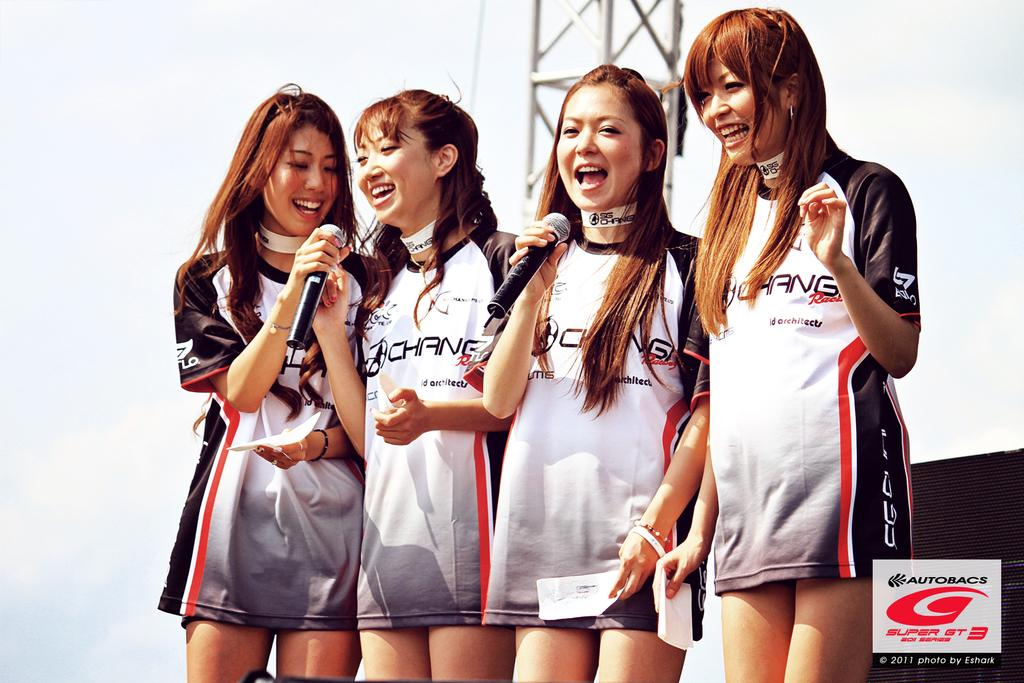<image>
Relay a brief, clear account of the picture shown. a group of girls that are wearing a jersey with the word chang on it 